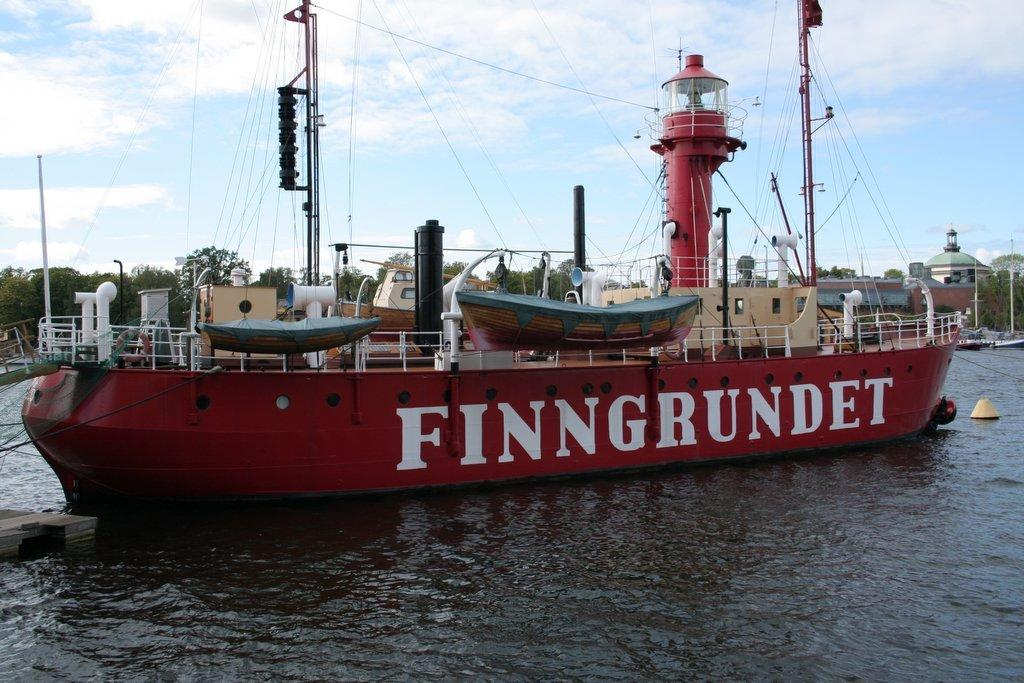What is the main subject of the image? The main subject of the image is a ship. Where is the ship located in the image? The ship is on the water. What else can be seen in the image besides the ship? There are poles with strings and trees in the background of the image. What is visible in the background of the image? The sky is visible in the background of the image. How do the pets interact with the ship in the image? There are no pets present in the image, so they cannot interact with the ship. What is the purpose of the twist in the image? There is no twist present in the image, so it cannot serve any purpose. 